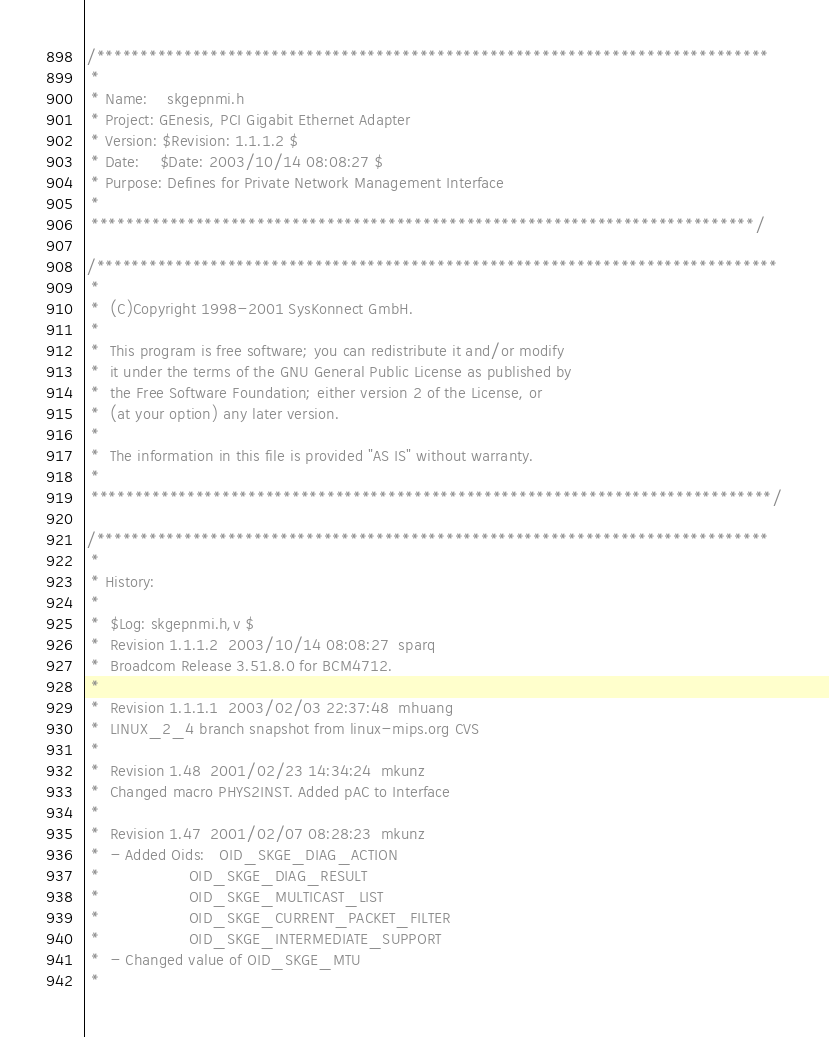Convert code to text. <code><loc_0><loc_0><loc_500><loc_500><_C_>/*****************************************************************************
 *
 * Name:	skgepnmi.h
 * Project:	GEnesis, PCI Gigabit Ethernet Adapter
 * Version:	$Revision: 1.1.1.2 $
 * Date:	$Date: 2003/10/14 08:08:27 $
 * Purpose:	Defines for Private Network Management Interface
 *
 ****************************************************************************/

/******************************************************************************
 *
 *	(C)Copyright 1998-2001 SysKonnect GmbH.
 *
 *	This program is free software; you can redistribute it and/or modify
 *	it under the terms of the GNU General Public License as published by
 *	the Free Software Foundation; either version 2 of the License, or
 *	(at your option) any later version.
 *
 *	The information in this file is provided "AS IS" without warranty.
 *
 ******************************************************************************/

/*****************************************************************************
 *
 * History:
 *
 *	$Log: skgepnmi.h,v $
 *	Revision 1.1.1.2  2003/10/14 08:08:27  sparq
 *	Broadcom Release 3.51.8.0 for BCM4712.
 *	
 *	Revision 1.1.1.1  2003/02/03 22:37:48  mhuang
 *	LINUX_2_4 branch snapshot from linux-mips.org CVS
 *	
 *	Revision 1.48  2001/02/23 14:34:24  mkunz
 *	Changed macro PHYS2INST. Added pAC to Interface
 *	
 *	Revision 1.47  2001/02/07 08:28:23  mkunz
 *	- Added Oids: 	OID_SKGE_DIAG_ACTION
 *					OID_SKGE_DIAG_RESULT
 *					OID_SKGE_MULTICAST_LIST
 *					OID_SKGE_CURRENT_PACKET_FILTER
 *					OID_SKGE_INTERMEDIATE_SUPPORT
 *	- Changed value of OID_SKGE_MTU
 *	</code> 